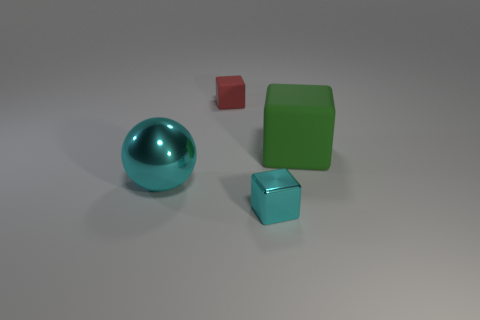Add 2 small cubes. How many objects exist? 6 Subtract all matte cubes. How many cubes are left? 1 Subtract all balls. How many objects are left? 3 Subtract 1 spheres. How many spheres are left? 0 Subtract all gray cubes. Subtract all gray balls. How many cubes are left? 3 Subtract all purple balls. How many red cubes are left? 1 Subtract all small metal blocks. Subtract all green blocks. How many objects are left? 2 Add 2 big metallic spheres. How many big metallic spheres are left? 3 Add 2 blue matte spheres. How many blue matte spheres exist? 2 Subtract 0 gray spheres. How many objects are left? 4 